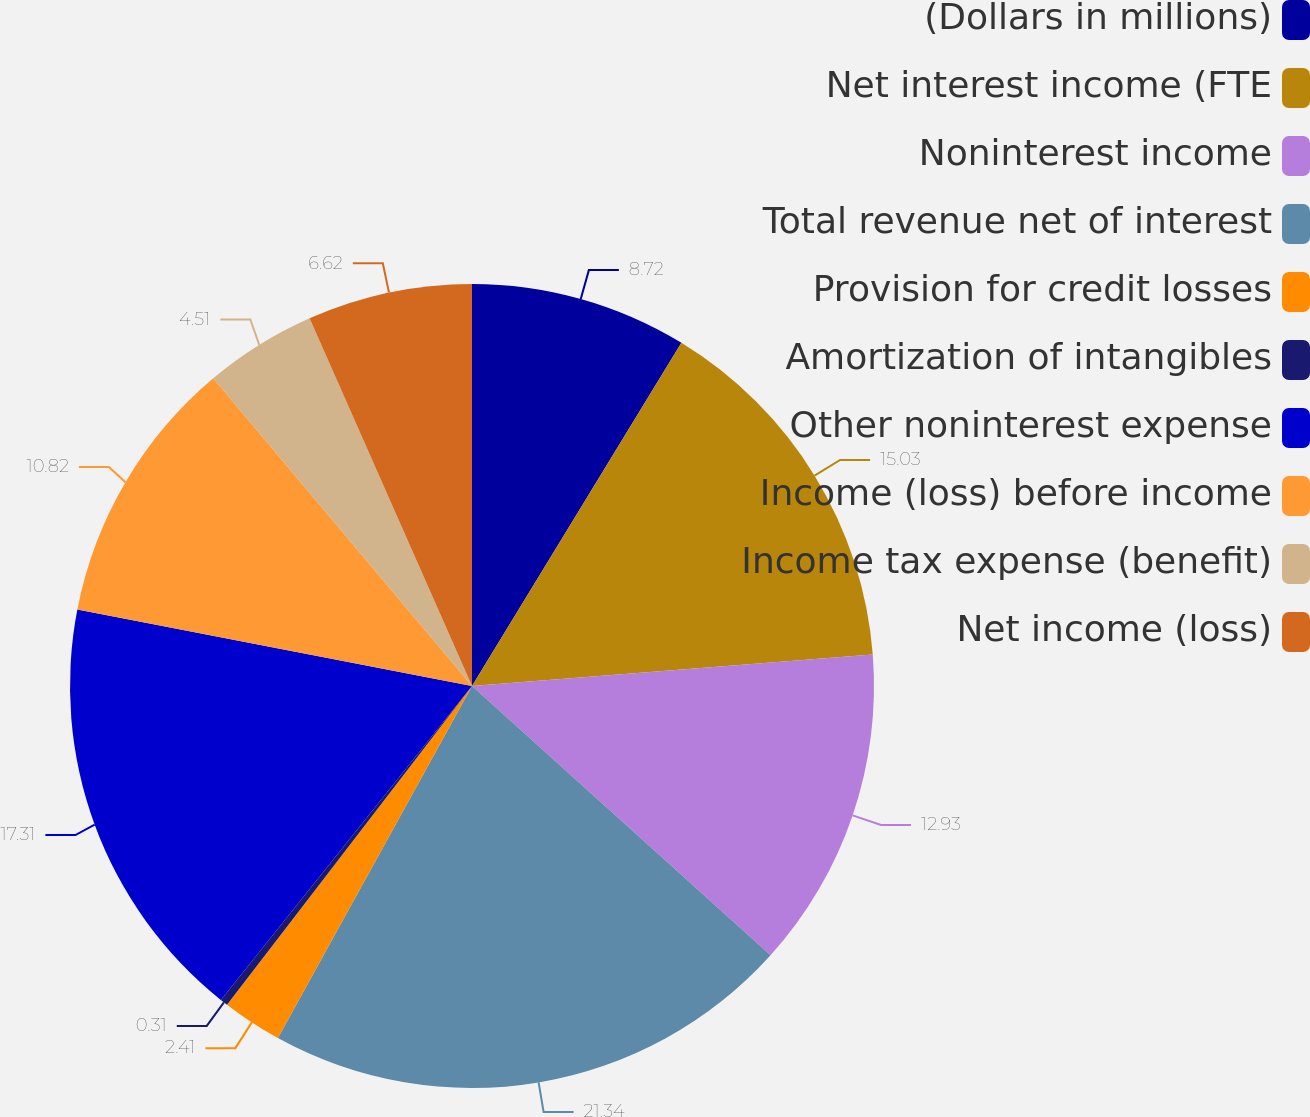Convert chart to OTSL. <chart><loc_0><loc_0><loc_500><loc_500><pie_chart><fcel>(Dollars in millions)<fcel>Net interest income (FTE<fcel>Noninterest income<fcel>Total revenue net of interest<fcel>Provision for credit losses<fcel>Amortization of intangibles<fcel>Other noninterest expense<fcel>Income (loss) before income<fcel>Income tax expense (benefit)<fcel>Net income (loss)<nl><fcel>8.72%<fcel>15.03%<fcel>12.93%<fcel>21.34%<fcel>2.41%<fcel>0.31%<fcel>17.31%<fcel>10.82%<fcel>4.51%<fcel>6.62%<nl></chart> 